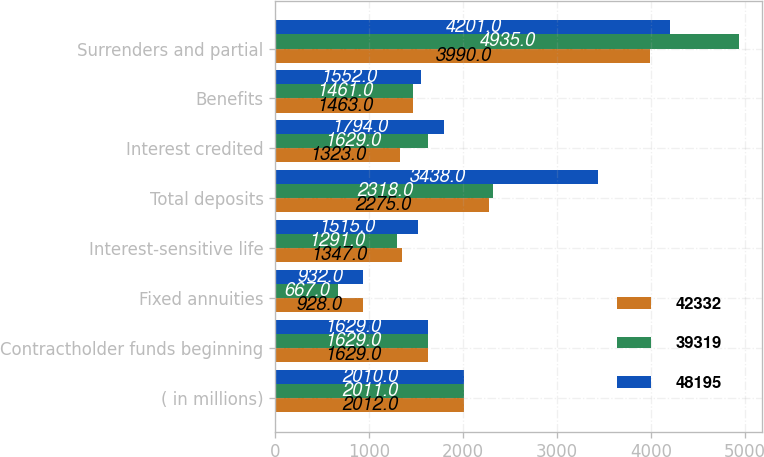<chart> <loc_0><loc_0><loc_500><loc_500><stacked_bar_chart><ecel><fcel>( in millions)<fcel>Contractholder funds beginning<fcel>Fixed annuities<fcel>Interest-sensitive life<fcel>Total deposits<fcel>Interest credited<fcel>Benefits<fcel>Surrenders and partial<nl><fcel>42332<fcel>2012<fcel>1629<fcel>928<fcel>1347<fcel>2275<fcel>1323<fcel>1463<fcel>3990<nl><fcel>39319<fcel>2011<fcel>1629<fcel>667<fcel>1291<fcel>2318<fcel>1629<fcel>1461<fcel>4935<nl><fcel>48195<fcel>2010<fcel>1629<fcel>932<fcel>1515<fcel>3438<fcel>1794<fcel>1552<fcel>4201<nl></chart> 